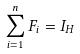<formula> <loc_0><loc_0><loc_500><loc_500>\sum _ { i = 1 } ^ { n } F _ { i } = I _ { H }</formula> 